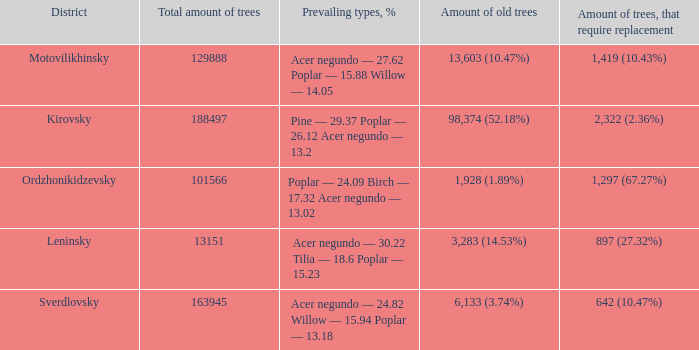What is the total amount of trees when district is leninsky? 13151.0. 